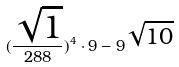Convert formula to latex. <formula><loc_0><loc_0><loc_500><loc_500>( \frac { \sqrt { 1 } } { 2 8 8 } ) ^ { 4 } \cdot 9 - 9 ^ { \sqrt { 1 0 } }</formula> 